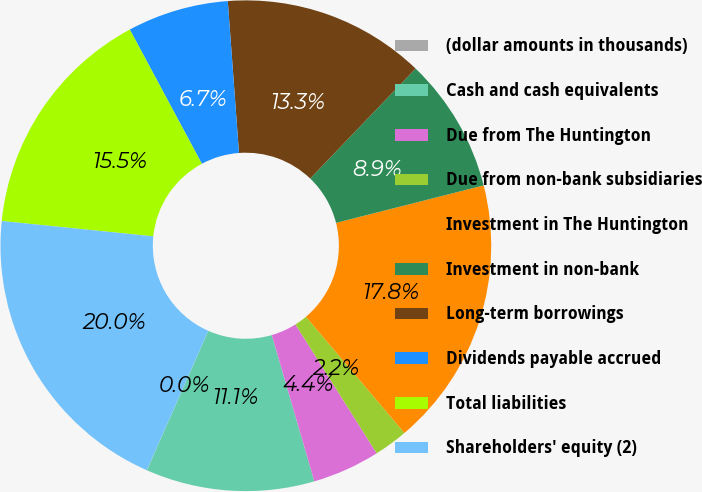Convert chart. <chart><loc_0><loc_0><loc_500><loc_500><pie_chart><fcel>(dollar amounts in thousands)<fcel>Cash and cash equivalents<fcel>Due from The Huntington<fcel>Due from non-bank subsidiaries<fcel>Investment in The Huntington<fcel>Investment in non-bank<fcel>Long-term borrowings<fcel>Dividends payable accrued<fcel>Total liabilities<fcel>Shareholders' equity (2)<nl><fcel>0.01%<fcel>11.11%<fcel>4.45%<fcel>2.23%<fcel>17.77%<fcel>8.89%<fcel>13.33%<fcel>6.67%<fcel>15.55%<fcel>19.99%<nl></chart> 